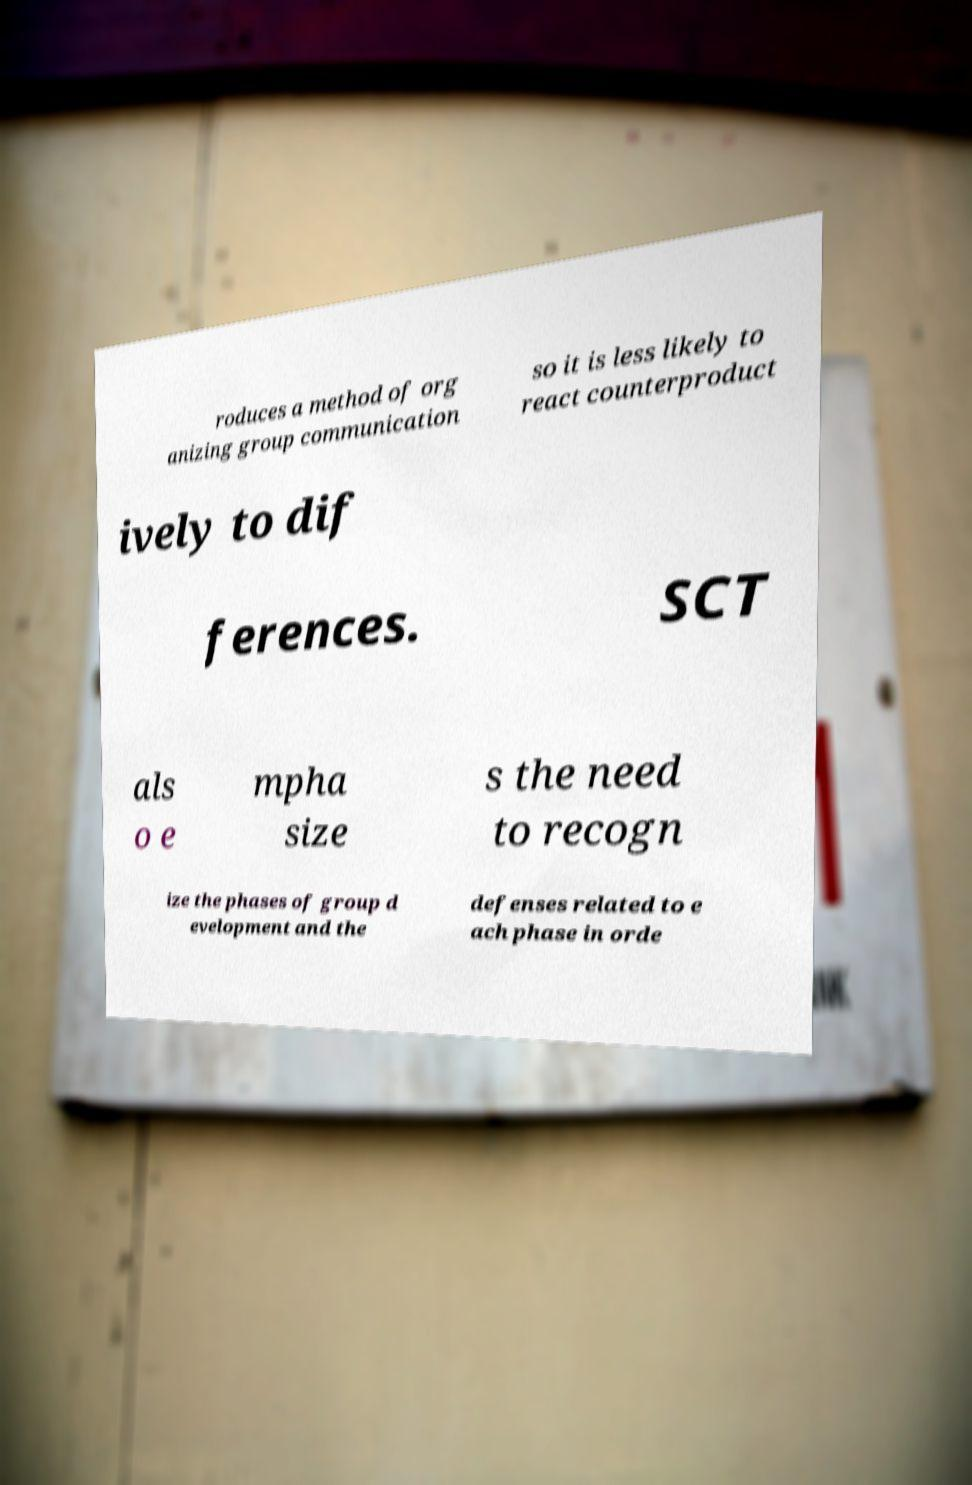What messages or text are displayed in this image? I need them in a readable, typed format. roduces a method of org anizing group communication so it is less likely to react counterproduct ively to dif ferences. SCT als o e mpha size s the need to recogn ize the phases of group d evelopment and the defenses related to e ach phase in orde 